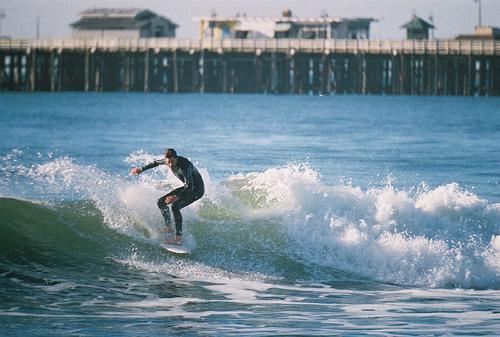How many people are pictured?
Give a very brief answer. 1. 